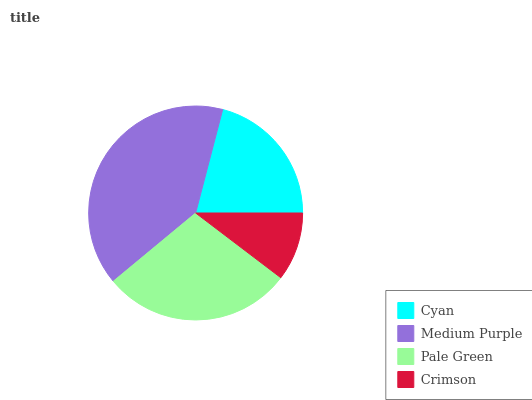Is Crimson the minimum?
Answer yes or no. Yes. Is Medium Purple the maximum?
Answer yes or no. Yes. Is Pale Green the minimum?
Answer yes or no. No. Is Pale Green the maximum?
Answer yes or no. No. Is Medium Purple greater than Pale Green?
Answer yes or no. Yes. Is Pale Green less than Medium Purple?
Answer yes or no. Yes. Is Pale Green greater than Medium Purple?
Answer yes or no. No. Is Medium Purple less than Pale Green?
Answer yes or no. No. Is Pale Green the high median?
Answer yes or no. Yes. Is Cyan the low median?
Answer yes or no. Yes. Is Medium Purple the high median?
Answer yes or no. No. Is Crimson the low median?
Answer yes or no. No. 